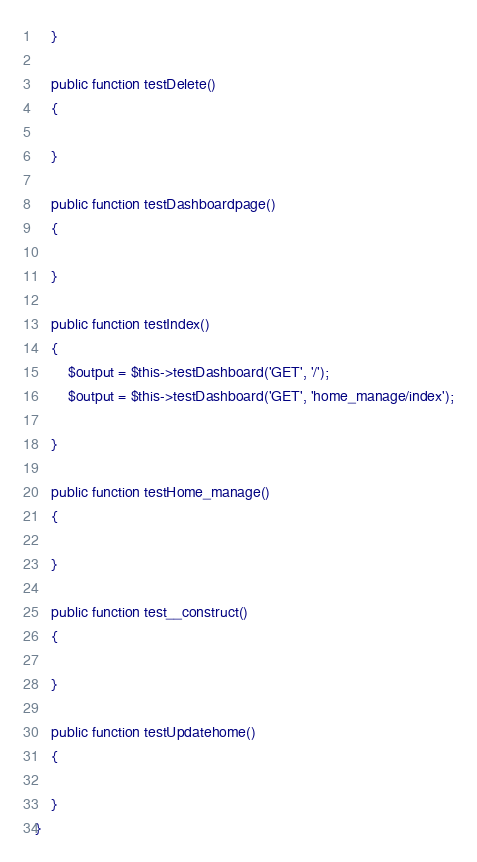<code> <loc_0><loc_0><loc_500><loc_500><_PHP_>
	}

	public function testDelete()
	{

	}

	public function testDashboardpage()
	{

	}

	public function testIndex()
	{
		$output = $this->testDashboard('GET', '/');
		$output = $this->testDashboard('GET', 'home_manage/index');

	}

	public function testHome_manage()
	{

	}

	public function test__construct()
	{

	}

	public function testUpdatehome()
	{

	}
}
</code> 